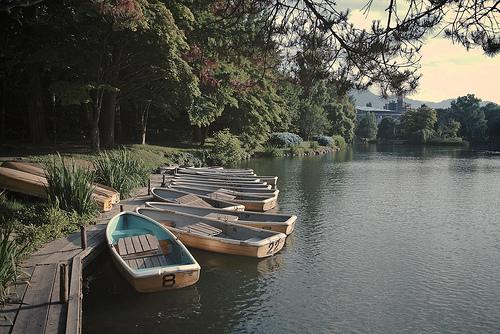Question: how are boats standing?
Choices:
A. Tied to dock.
B. In dry dock.
C. In a line.
D. Randomly.
Answer with the letter. Answer: C Question: how is the day?
Choices:
A. Tiring.
B. Cold.
C. Sunny.
D. Windy.
Answer with the letter. Answer: C 